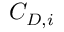Convert formula to latex. <formula><loc_0><loc_0><loc_500><loc_500>C _ { D , i }</formula> 